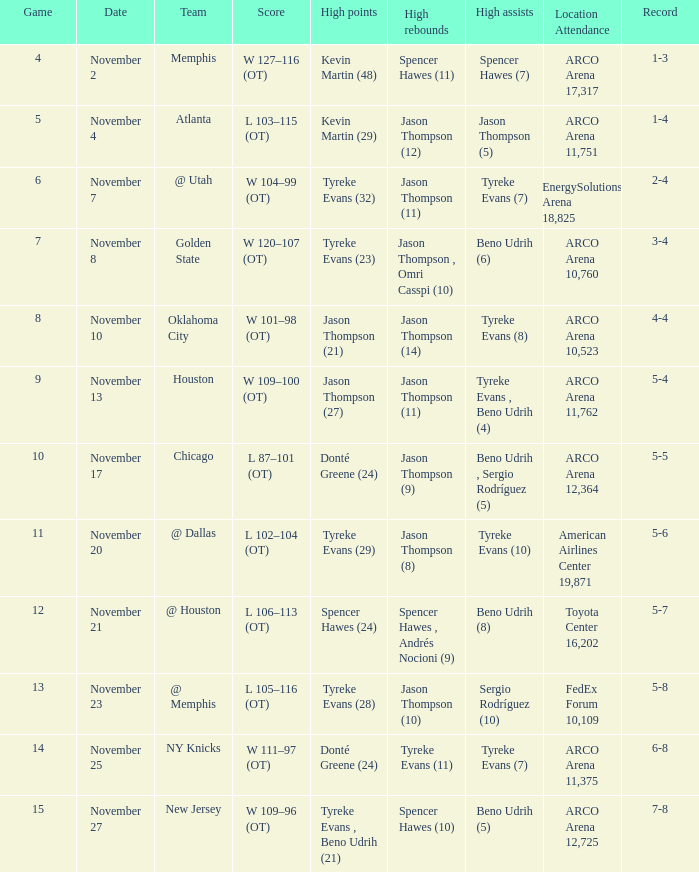If the record is 5-8, what is the team name? @ Memphis. 